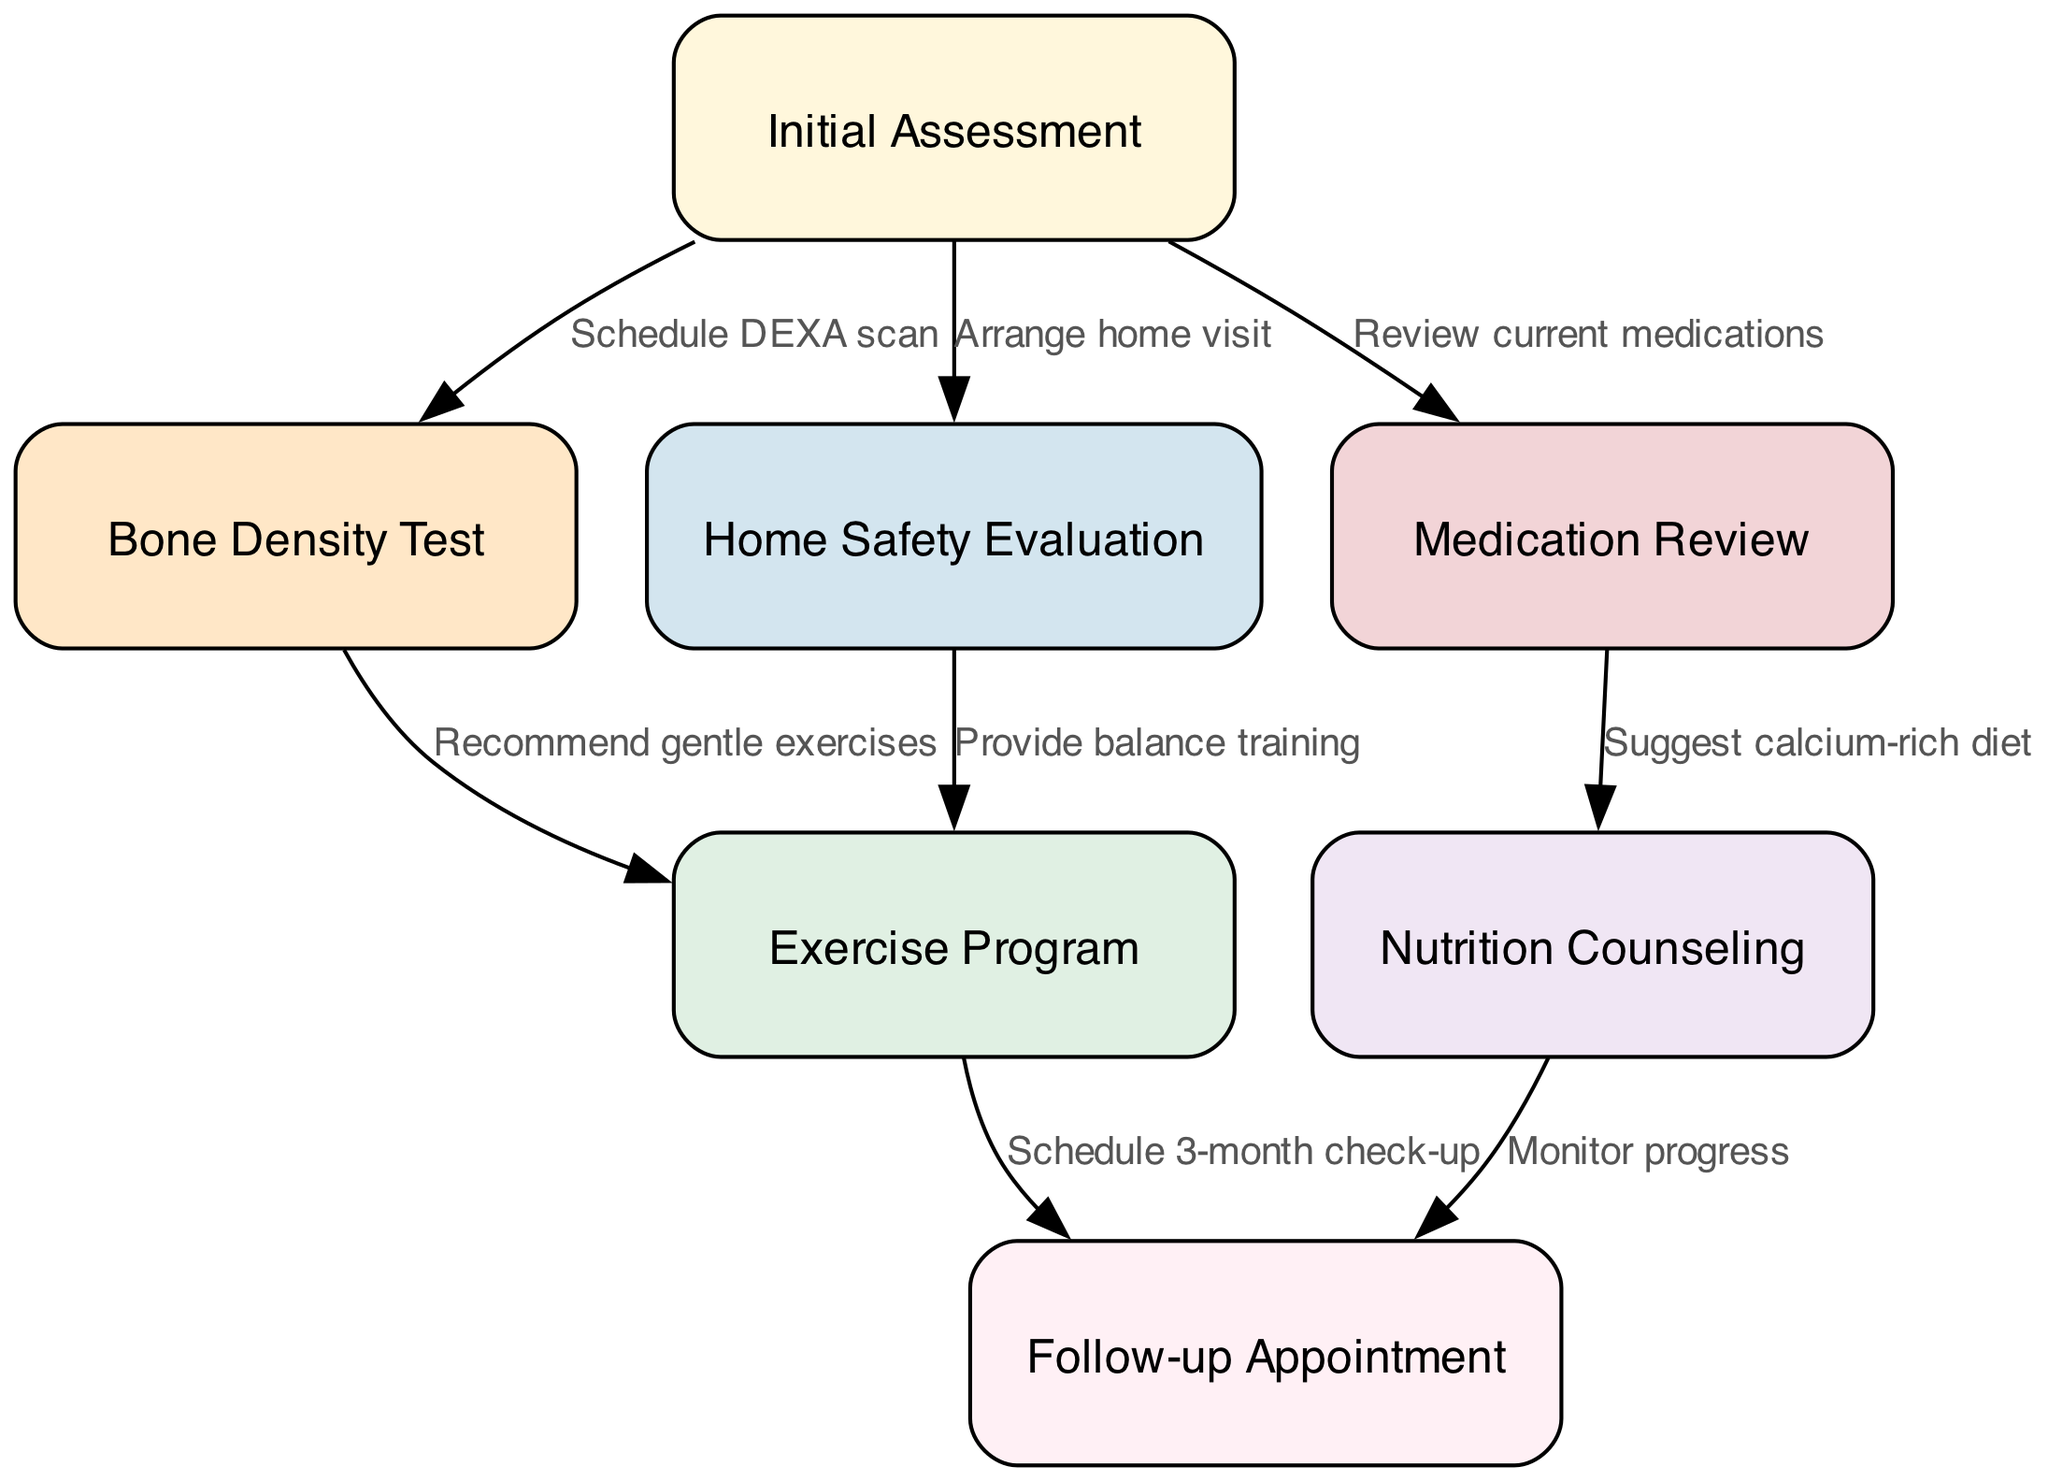What is the first step in the clinical pathway? The first step, as indicated in the diagram, is "Initial Assessment," which is the starting point for gathering relevant information about the patient.
Answer: Initial Assessment How many nodes are present in the diagram? The diagram includes a total of seven nodes, each representing a key component of the fall prevention and osteoporosis management strategy.
Answer: 7 What follows the "Bone Density Test"? After the "Bone Density Test," the next step is to implement the "Exercise Program," which is recommended based on the results of the bone density test.
Answer: Exercise Program What is scheduled after the "Exercise Program"? Following the "Exercise Program," a "Follow-up Appointment" is scheduled to assess the patient's progress and plan future care.
Answer: Follow-up Appointment What is suggested during the "Medication Review"? During the "Medication Review," it is suggested to include a "calcium-rich diet" as part of the osteoporosis management strategy for better bone health.
Answer: Suggest calcium-rich diet Which node is connected to both "Home Safety Evaluation" and "Exercise Program"? The "Exercise Program" is connected to the "Home Safety Evaluation" as it emphasizes balance training, which helps in preventing falls, thereby linking these two nodes.
Answer: Exercise Program How many edges are in the diagram? There are a total of six edges, which represent the connections and relationships between the different nodes in the pathway.
Answer: 6 What does the edge from "Bone Density Test" to "Exercise Program" represent? The edge from "Bone Density Test" to "Exercise Program" represents a recommendation for "gentle exercises" based on the results of the bone density test, showing the flow of care.
Answer: Recommend gentle exercises What type of evaluation follows after "Home Safety Evaluation"? After the "Home Safety Evaluation," the next evaluation step involves "Balance training," which is designed to enhance safety and reduce the risk of falls at home.
Answer: Balance training 